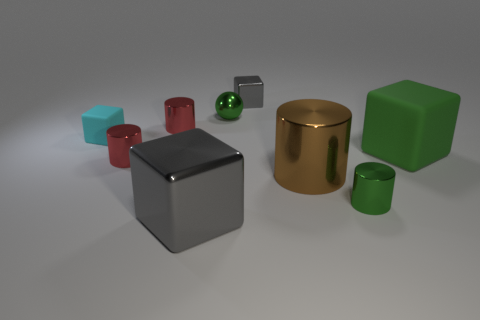Is the number of gray metallic cubes behind the tiny green metallic cylinder less than the number of shiny cylinders in front of the green rubber cube?
Your response must be concise. Yes. What is the shape of the gray thing that is behind the matte cube in front of the rubber cube that is behind the large green thing?
Offer a very short reply. Cube. There is a small shiny object that is both on the left side of the small green metallic cylinder and in front of the large green block; what shape is it?
Provide a succinct answer. Cylinder. Are there any red things made of the same material as the green ball?
Your response must be concise. Yes. There is a metallic object that is the same color as the tiny shiny sphere; what size is it?
Your answer should be very brief. Small. The small cylinder that is behind the large rubber thing is what color?
Make the answer very short. Red. Does the cyan object have the same shape as the matte thing that is right of the cyan block?
Ensure brevity in your answer.  Yes. Is there a small matte cube of the same color as the metallic ball?
Provide a short and direct response. No. There is a brown thing that is the same material as the large gray cube; what size is it?
Keep it short and to the point. Large. Does the shiny ball have the same color as the big matte object?
Ensure brevity in your answer.  Yes. 